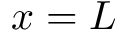<formula> <loc_0><loc_0><loc_500><loc_500>x = L</formula> 